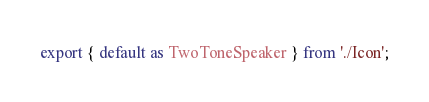<code> <loc_0><loc_0><loc_500><loc_500><_TypeScript_>export { default as TwoToneSpeaker } from './Icon';
</code> 